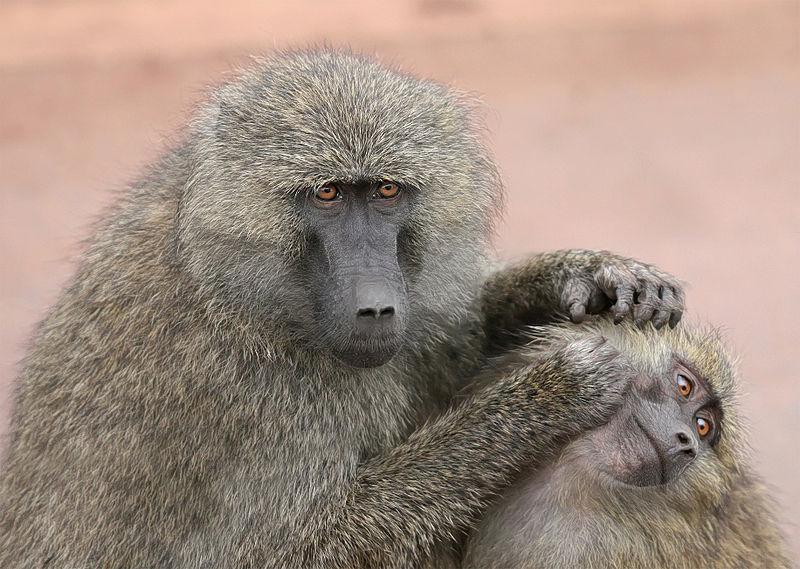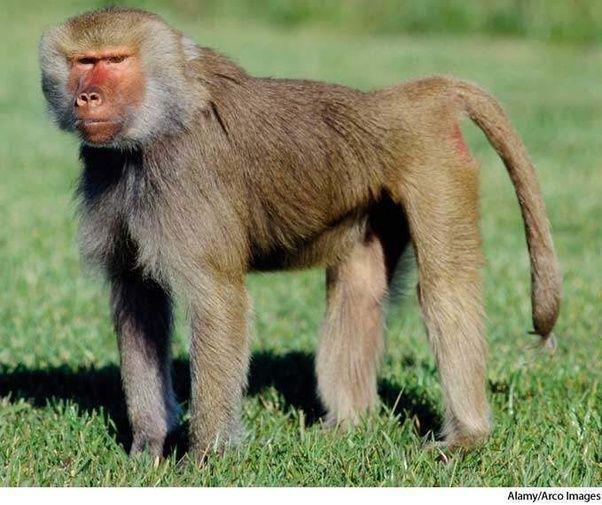The first image is the image on the left, the second image is the image on the right. For the images displayed, is the sentence "An image shows a baboon standing on all fours with part of its bulbous pink hairless rear showing." factually correct? Answer yes or no. No. 